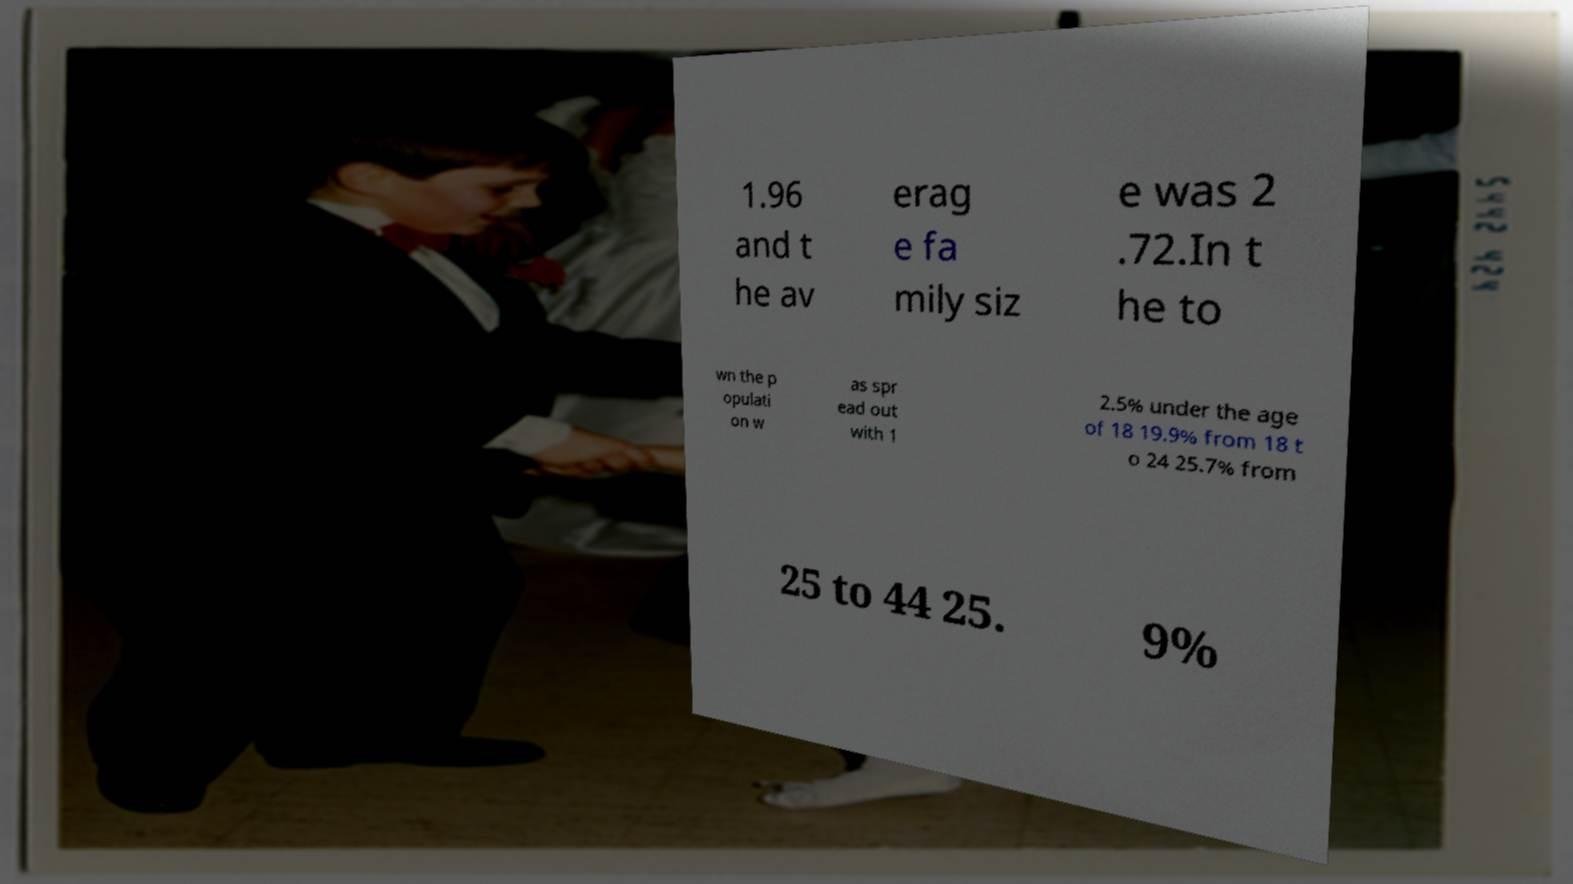Could you assist in decoding the text presented in this image and type it out clearly? 1.96 and t he av erag e fa mily siz e was 2 .72.In t he to wn the p opulati on w as spr ead out with 1 2.5% under the age of 18 19.9% from 18 t o 24 25.7% from 25 to 44 25. 9% 